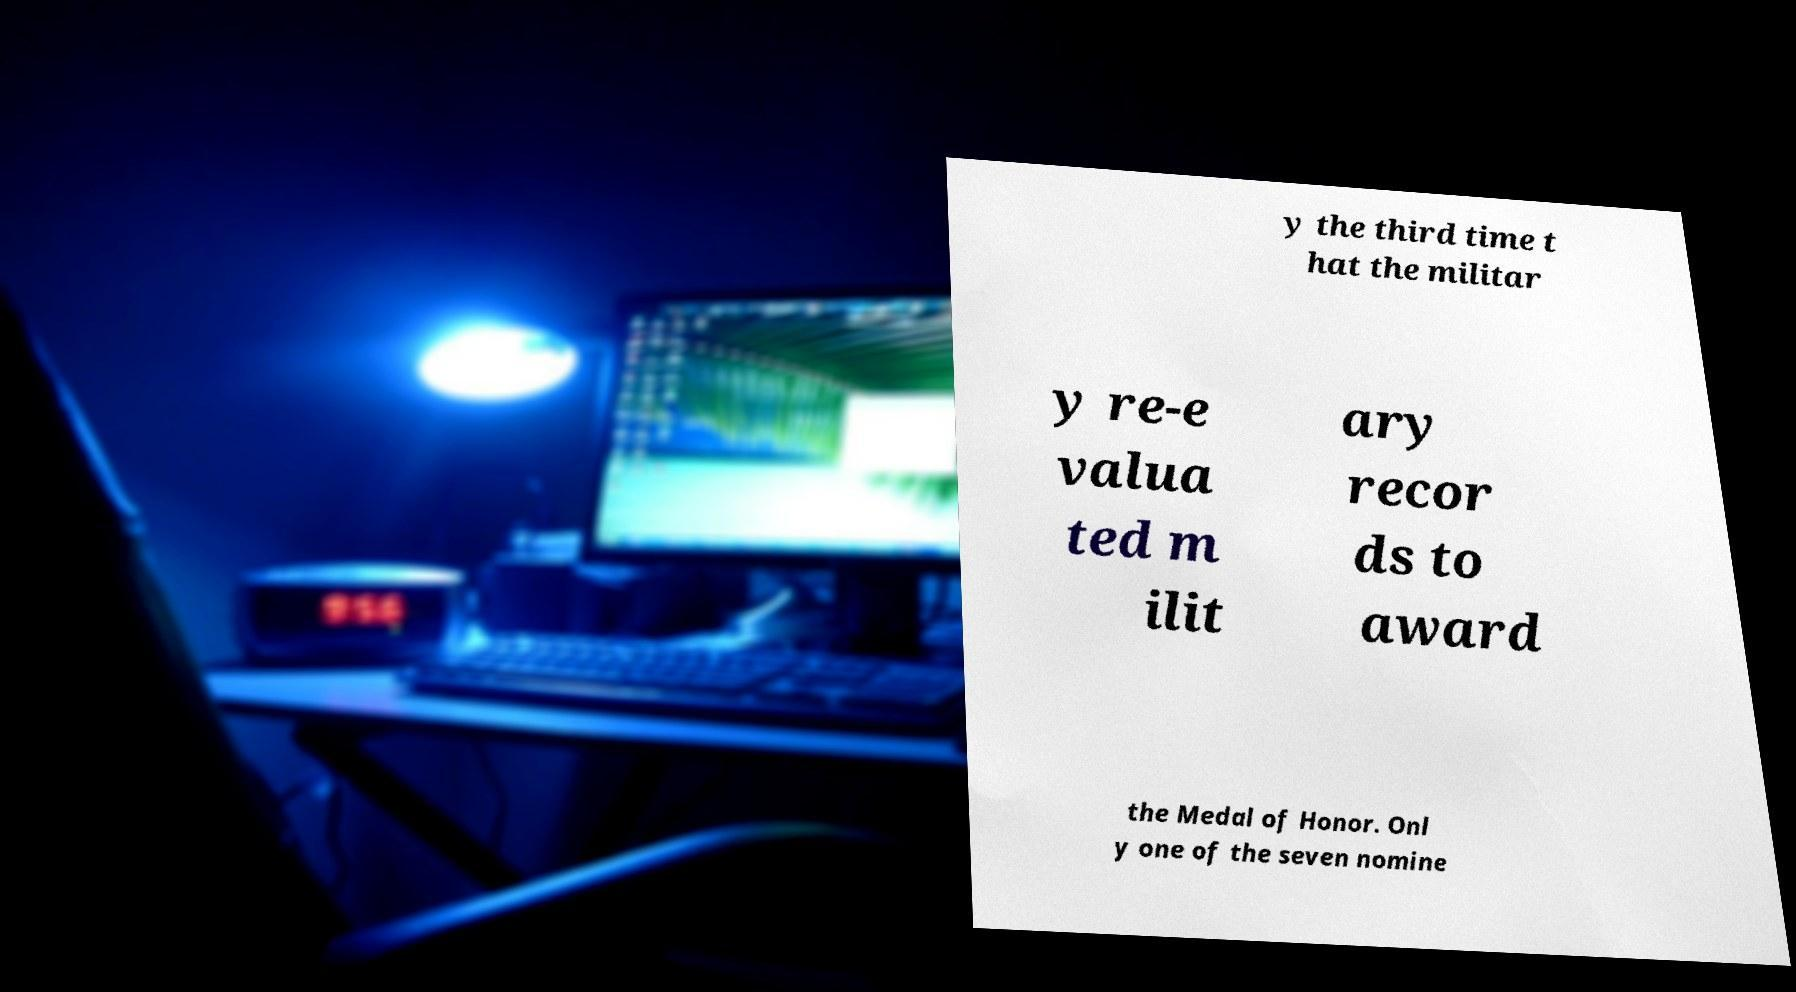What messages or text are displayed in this image? I need them in a readable, typed format. y the third time t hat the militar y re-e valua ted m ilit ary recor ds to award the Medal of Honor. Onl y one of the seven nomine 